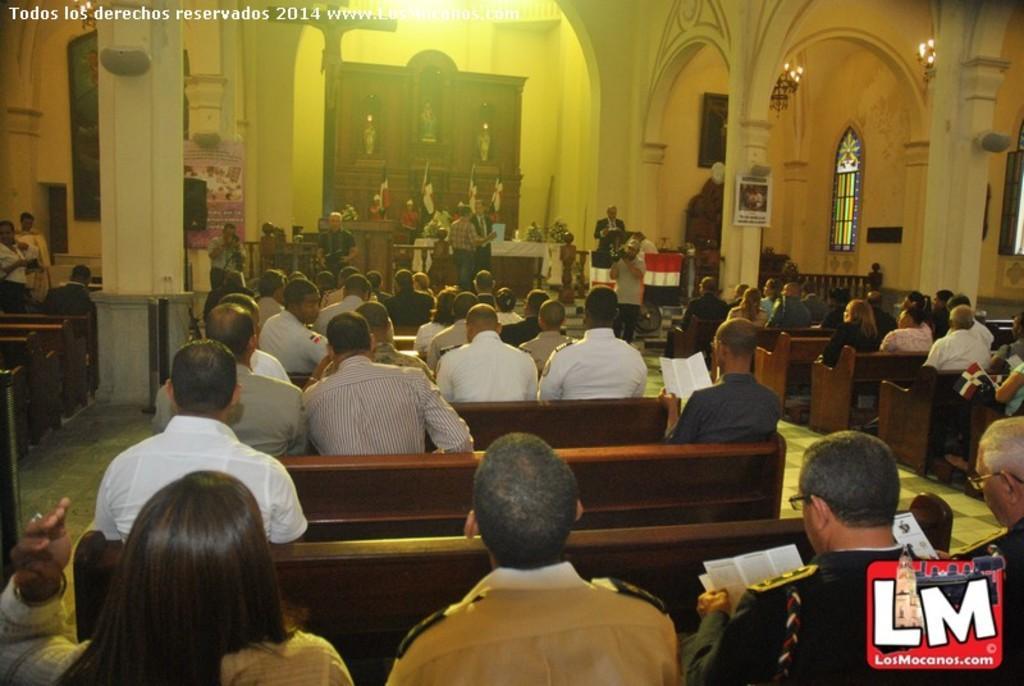Can you describe this image briefly? In this image we can see a group of people sitting on the benches. In that some are holding the papers. We can also see the flags, some people standing, two people holding the cameras, the flags, pillars, windows, boards with some text on them, frames on a wall, statues and the chandeliers to a roof. 